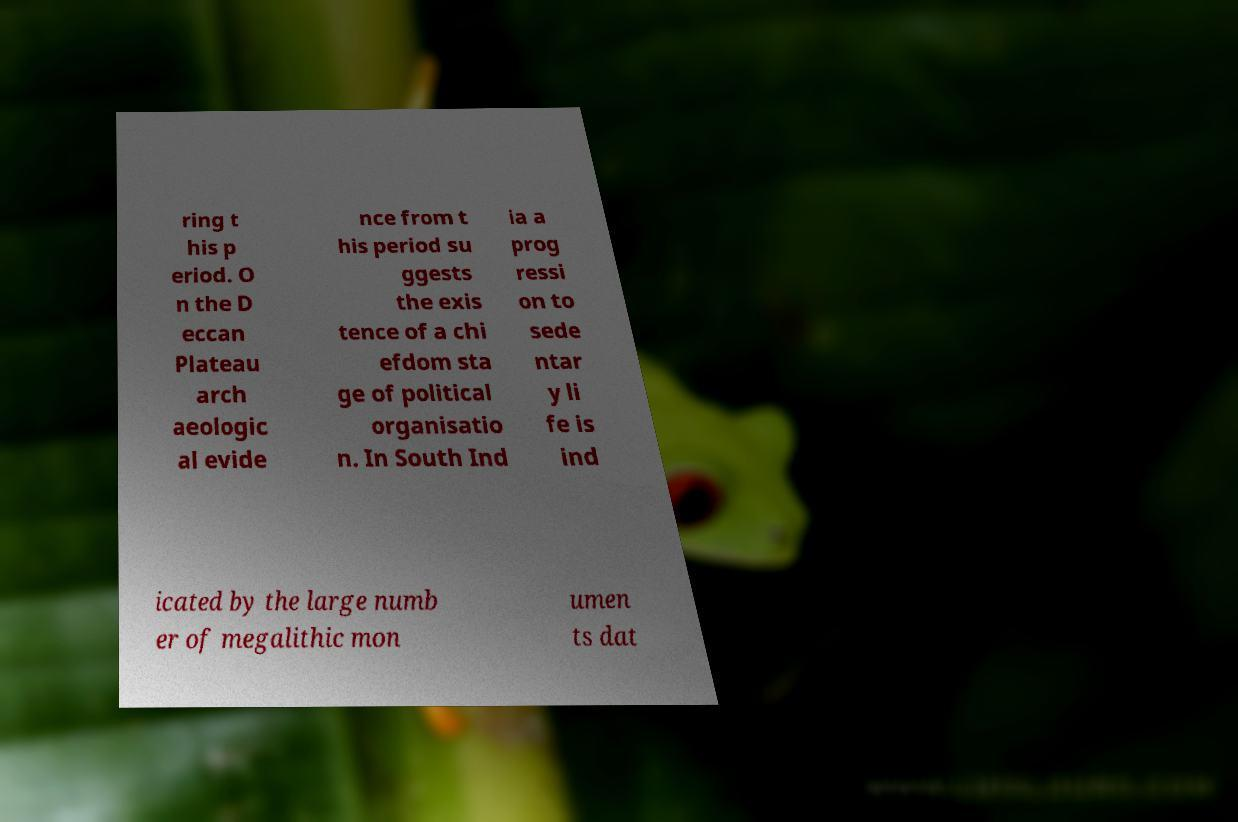Can you read and provide the text displayed in the image?This photo seems to have some interesting text. Can you extract and type it out for me? ring t his p eriod. O n the D eccan Plateau arch aeologic al evide nce from t his period su ggests the exis tence of a chi efdom sta ge of political organisatio n. In South Ind ia a prog ressi on to sede ntar y li fe is ind icated by the large numb er of megalithic mon umen ts dat 